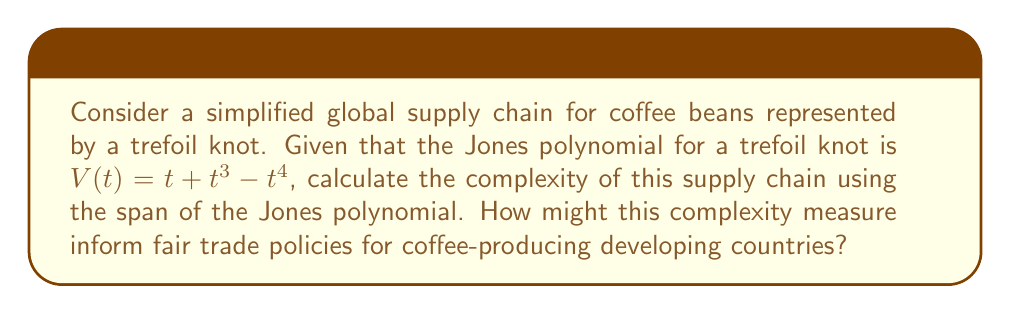What is the answer to this math problem? To solve this problem, we'll follow these steps:

1) Recall that the span of a polynomial is the difference between its highest and lowest exponents.

2) For the given Jones polynomial $V(t) = t + t^3 - t^4$:
   - Highest exponent: 4
   - Lowest exponent: 1

3) Calculate the span:
   $\text{span} = \text{highest exponent} - \text{lowest exponent}$
   $\text{span} = 4 - 1 = 3$

4) In knot theory, the span of the Jones polynomial is a measure of knot complexity. A higher span indicates a more complex knot.

5) Interpreting this in the context of global supply chains:
   - The span of 3 suggests a moderately complex supply chain.
   - This complexity could represent various stages in coffee production, processing, and distribution.

6) Implications for fair trade policies:
   - Higher complexity may indicate more intermediaries in the supply chain.
   - This could potentially reduce the share of profits reaching coffee farmers in developing countries.
   - Fair trade policies could aim to simplify the supply chain (reduce the "knot complexity") or ensure fair compensation at each stage.
Answer: Span of Jones polynomial: 3; indicates moderate supply chain complexity, suggesting need for fair trade policies to address multiple intermediaries or ensure equitable profit distribution. 